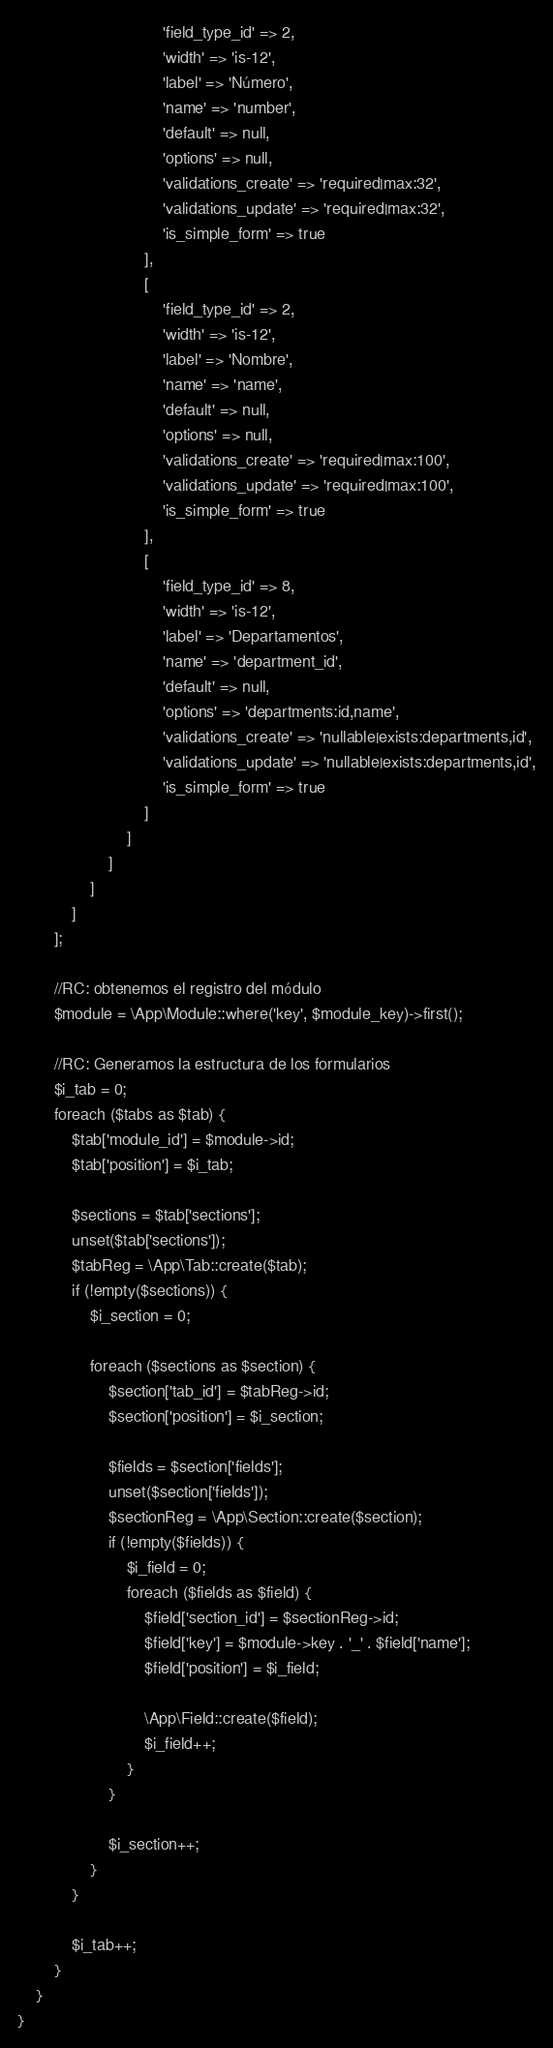Convert code to text. <code><loc_0><loc_0><loc_500><loc_500><_PHP_>                                'field_type_id' => 2,
                                'width' => 'is-12',
                                'label' => 'Número',
                                'name' => 'number',
                                'default' => null,
                                'options' => null,
                                'validations_create' => 'required|max:32',
                                'validations_update' => 'required|max:32',
                                'is_simple_form' => true
                            ],
                            [
                                'field_type_id' => 2,
                                'width' => 'is-12',
                                'label' => 'Nombre',
                                'name' => 'name',
                                'default' => null,
                                'options' => null,
                                'validations_create' => 'required|max:100',
                                'validations_update' => 'required|max:100',
                                'is_simple_form' => true
                            ],
                            [
                                'field_type_id' => 8,
                                'width' => 'is-12',
                                'label' => 'Departamentos',
                                'name' => 'department_id',
                                'default' => null,
                                'options' => 'departments:id,name',
                                'validations_create' => 'nullable|exists:departments,id',
                                'validations_update' => 'nullable|exists:departments,id',
                                'is_simple_form' => true
                            ]
                        ]
                    ]
                ]
            ]
        ];

        //RC: obtenemos el registro del módulo
        $module = \App\Module::where('key', $module_key)->first();

        //RC: Generamos la estructura de los formularios
        $i_tab = 0;
        foreach ($tabs as $tab) {
            $tab['module_id'] = $module->id;
            $tab['position'] = $i_tab;

            $sections = $tab['sections'];
            unset($tab['sections']);
            $tabReg = \App\Tab::create($tab);
            if (!empty($sections)) {
                $i_section = 0;

                foreach ($sections as $section) {
                    $section['tab_id'] = $tabReg->id;
                    $section['position'] = $i_section;

                    $fields = $section['fields'];
                    unset($section['fields']);
                    $sectionReg = \App\Section::create($section);
                    if (!empty($fields)) {
                        $i_field = 0;
                        foreach ($fields as $field) {
                            $field['section_id'] = $sectionReg->id;
                            $field['key'] = $module->key . '_' . $field['name'];
                            $field['position'] = $i_field;

                            \App\Field::create($field);
                            $i_field++;
                        }
                    }

                    $i_section++;
                }
            }

            $i_tab++;
        }
    }
}
</code> 